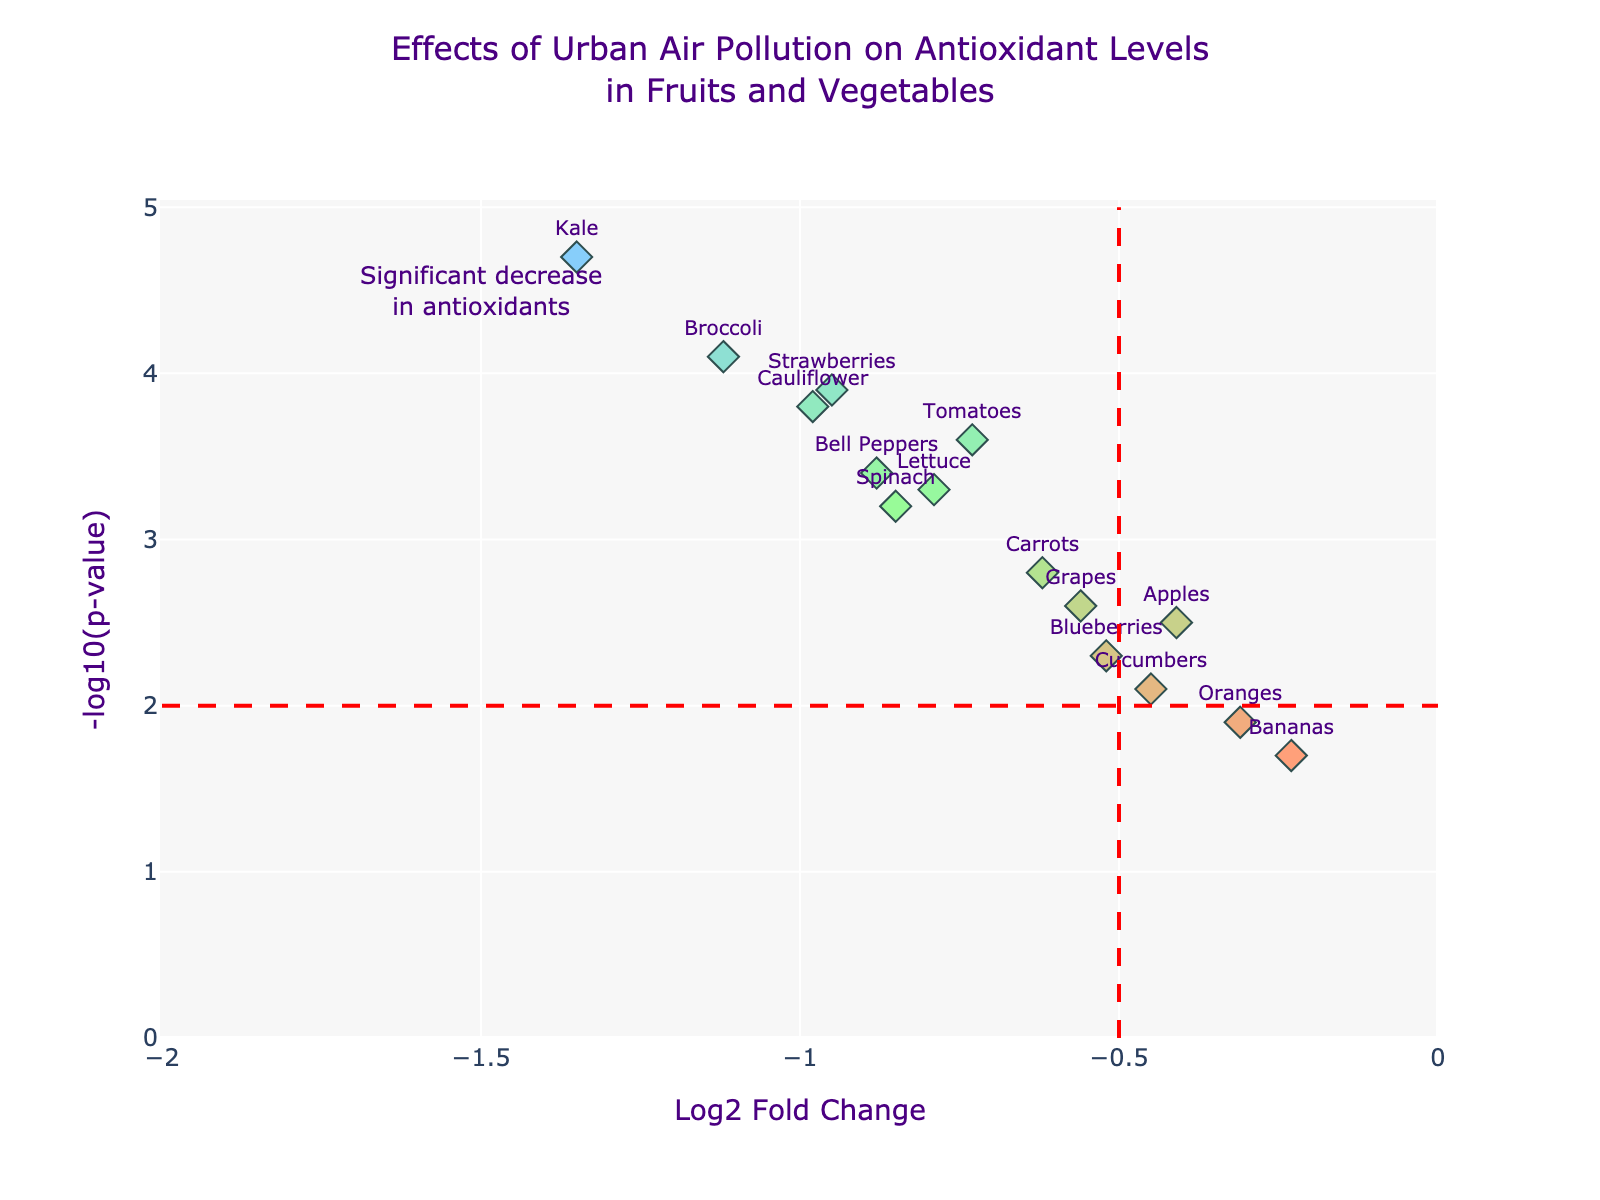What is the title of the figure? The title of the figure is displayed at the top, and it reads, "Effects of Urban Air Pollution on Antioxidant Levels in Fruits and Vegetables."
Answer: Effects of Urban Air Pollution on Antioxidant Levels in Fruits and Vegetables What do the x-axis and y-axis represent? The x-axis represents the "Log2 Fold Change," and the y-axis represents the "-log10(p-value)" of antioxidant levels in fruits and vegetables.
Answer: Log2 Fold Change and -log10(p-value) Which fruit or vegetable has the highest -log10(p-value)? By looking at the y-axis, Kale has the highest -log10(p-value) at 4.7.
Answer: Kale Which fruit or vegetable experienced the largest decrease in antioxidant levels? The largest decrease in antioxidant levels corresponds to the smallest Log2 Fold Change. Kale has the smallest value at -1.35.
Answer: Kale How many fruits and vegetables fall below the significance line at -log10(p-value) = 2? Count all the data points below the horizontal red dashed line which indicates -log10(p-value) = 2. There are 4 fruits/vegetables: Bananas, Oranges, Blueberries, and Cucumbers.
Answer: 4 Which fruit or vegetable is closest to the vertical significance line at Log2 Fold Change = -0.5? Find the data point nearest to the vertical red dashed line at Log2 Fold Change = -0.5. Cucumbers are the closest, with a Log2 Fold Change of -0.45.
Answer: Cucumbers Compare the antioxidant levels of Kale and Lettuce in terms of fold change and p-value. The Log2 Fold Change of Kale is -1.35, and its -log10(p-value) is 4.7. Lettuce has a Log2 Fold Change of -0.79 and a -log10(p-value) of 3.3. Kale has a larger decrease in antioxidant levels and a more significant p-value than Lettuce.
Answer: Kale decreased more significantly Which fruits and vegetables have a -log10(p-value) greater than 3? All data points with a -log10(p-value) greater than 3 are visualized above the value of 3 on the y-axis. These include Kale, Broccoli, Strawberries, Cauliflower, Spinach, Tomatoes, Bell Peppers, and Lettuce.
Answer: 8 (Kale, Broccoli, Strawberries, Cauliflower, Spinach, Tomatoes, Bell Peppers, Lettuce) What is the Log2 Fold Change range of the data points on this plot? The Log2 Fold Change values range from the smallest value to the largest value. The smallest value is Kale at -1.35, and the largest value is Bananas at -0.23.
Answer: -1.35 to -0.23 Which fruit or vegetable has the lowest -log10(p-value)? The lowest -log10(p-value) corresponds to the smallest value on the y-axis. Bananas have the lowest -log10(p-value) at 1.7.
Answer: Bananas 